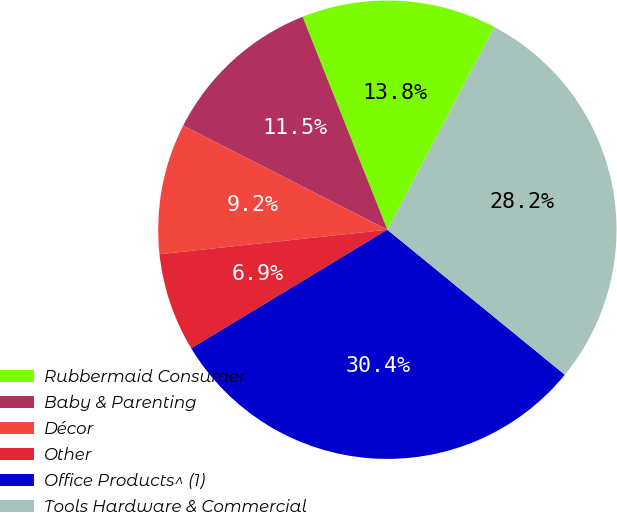Convert chart to OTSL. <chart><loc_0><loc_0><loc_500><loc_500><pie_chart><fcel>Rubbermaid Consumer<fcel>Baby & Parenting<fcel>Décor<fcel>Other<fcel>Office Products^ (1)<fcel>Tools Hardware & Commercial<nl><fcel>13.75%<fcel>11.47%<fcel>9.21%<fcel>6.95%<fcel>30.44%<fcel>28.18%<nl></chart> 